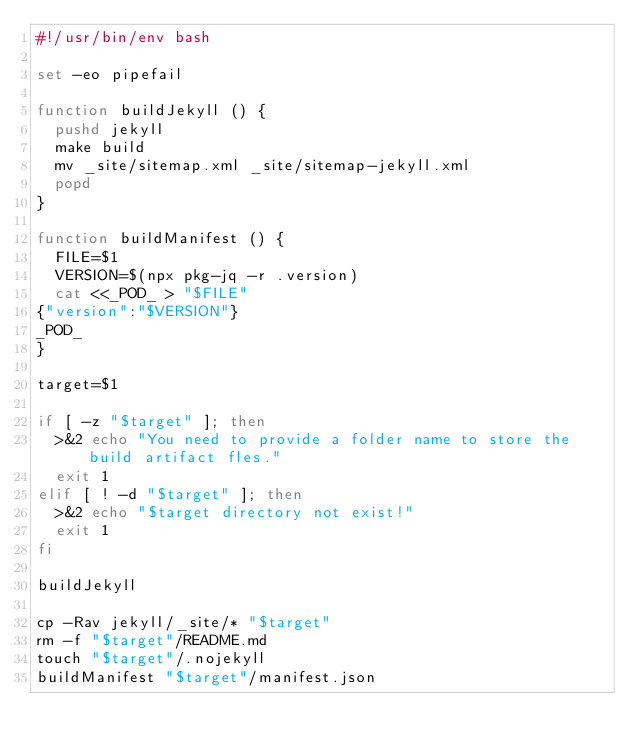Convert code to text. <code><loc_0><loc_0><loc_500><loc_500><_Bash_>#!/usr/bin/env bash

set -eo pipefail

function buildJekyll () {
  pushd jekyll
  make build
  mv _site/sitemap.xml _site/sitemap-jekyll.xml
  popd
}

function buildManifest () {
  FILE=$1
  VERSION=$(npx pkg-jq -r .version)
  cat <<_POD_ > "$FILE"
{"version":"$VERSION"}
_POD_
}

target=$1

if [ -z "$target" ]; then
  >&2 echo "You need to provide a folder name to store the build artifact fles."
  exit 1
elif [ ! -d "$target" ]; then
  >&2 echo "$target directory not exist!"
  exit 1
fi

buildJekyll

cp -Rav jekyll/_site/* "$target"
rm -f "$target"/README.md
touch "$target"/.nojekyll
buildManifest "$target"/manifest.json
</code> 